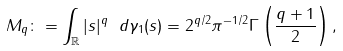<formula> <loc_0><loc_0><loc_500><loc_500>M _ { q } \colon = \int _ { \mathbb { R } } | s | ^ { q } \ d \gamma _ { 1 } ( s ) = 2 ^ { q / 2 } \pi ^ { - 1 / 2 } \Gamma \left ( \frac { q + 1 } { 2 } \right ) ,</formula> 